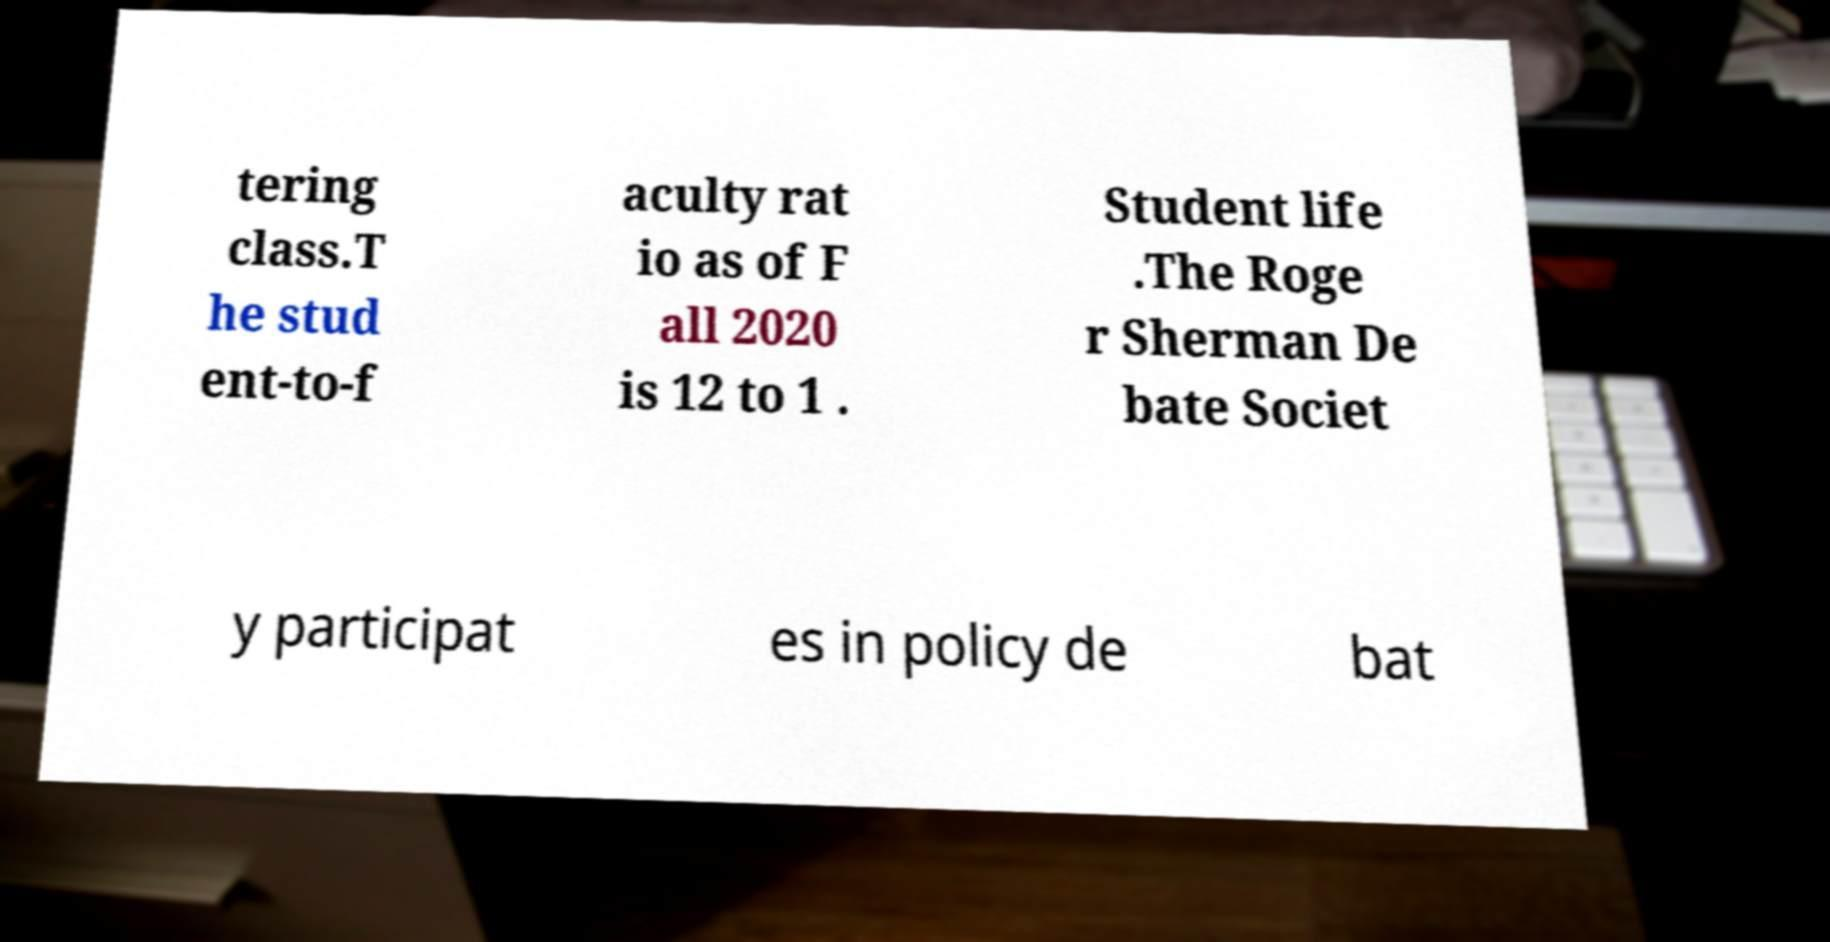What messages or text are displayed in this image? I need them in a readable, typed format. tering class.T he stud ent-to-f aculty rat io as of F all 2020 is 12 to 1 . Student life .The Roge r Sherman De bate Societ y participat es in policy de bat 